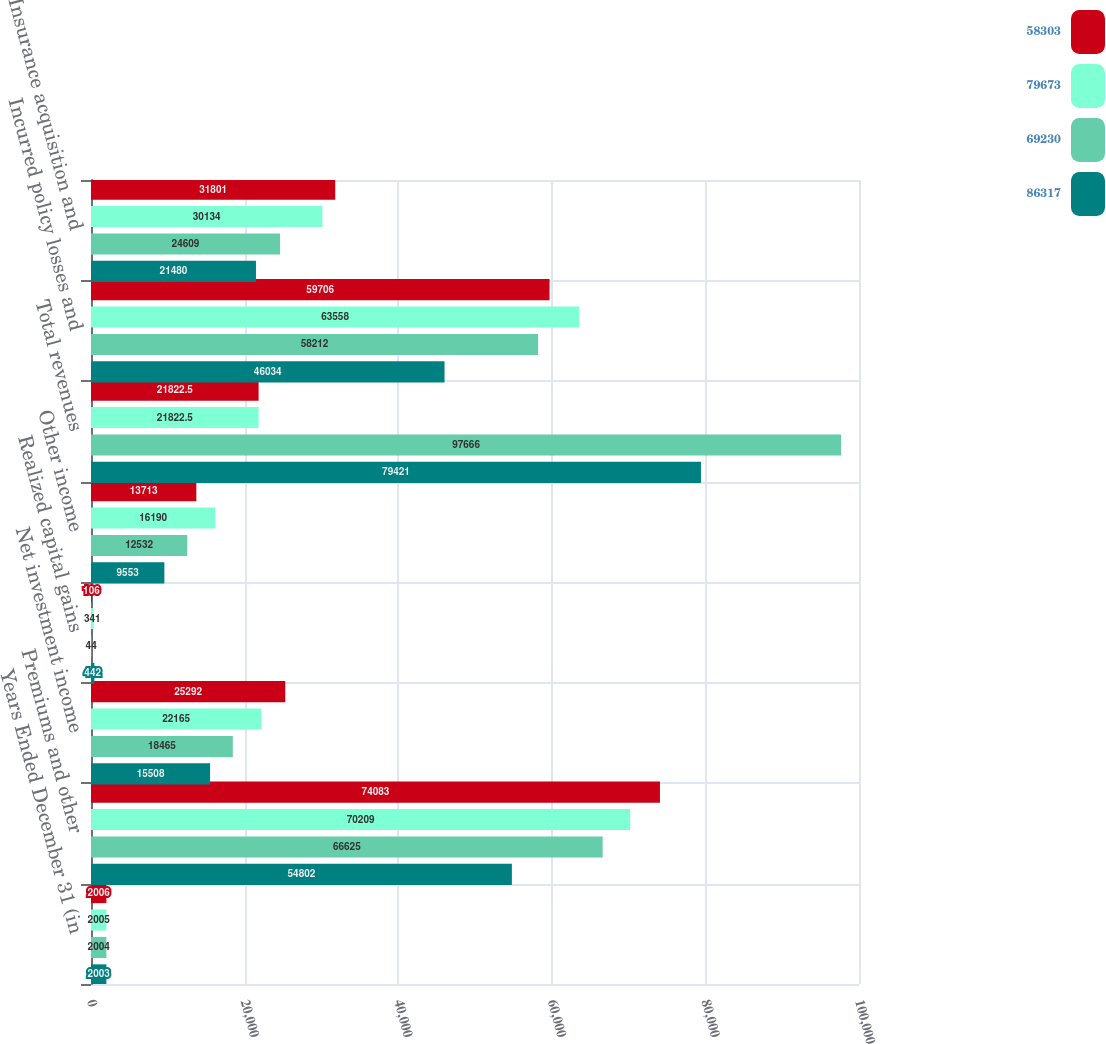Convert chart to OTSL. <chart><loc_0><loc_0><loc_500><loc_500><stacked_bar_chart><ecel><fcel>Years Ended December 31 (in<fcel>Premiums and other<fcel>Net investment income<fcel>Realized capital gains<fcel>Other income<fcel>Total revenues<fcel>Incurred policy losses and<fcel>Insurance acquisition and<nl><fcel>58303<fcel>2006<fcel>74083<fcel>25292<fcel>106<fcel>13713<fcel>21822.5<fcel>59706<fcel>31801<nl><fcel>79673<fcel>2005<fcel>70209<fcel>22165<fcel>341<fcel>16190<fcel>21822.5<fcel>63558<fcel>30134<nl><fcel>69230<fcel>2004<fcel>66625<fcel>18465<fcel>44<fcel>12532<fcel>97666<fcel>58212<fcel>24609<nl><fcel>86317<fcel>2003<fcel>54802<fcel>15508<fcel>442<fcel>9553<fcel>79421<fcel>46034<fcel>21480<nl></chart> 